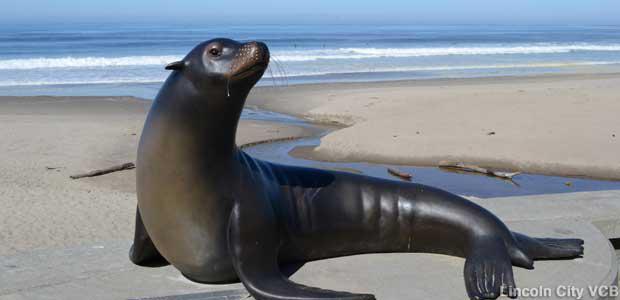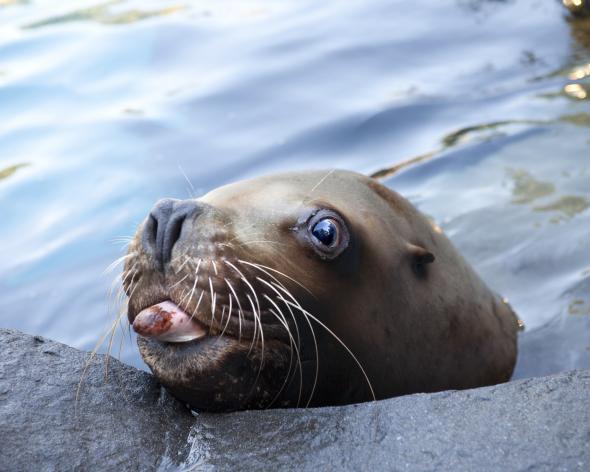The first image is the image on the left, the second image is the image on the right. Analyze the images presented: Is the assertion "The seals in the image on the right are sunning on a rock." valid? Answer yes or no. No. The first image is the image on the left, the second image is the image on the right. Analyze the images presented: Is the assertion "One image includes a close-mouthed seal with its face poking up out of the water, and the other image includes multiple seals at the edge of water." valid? Answer yes or no. No. 